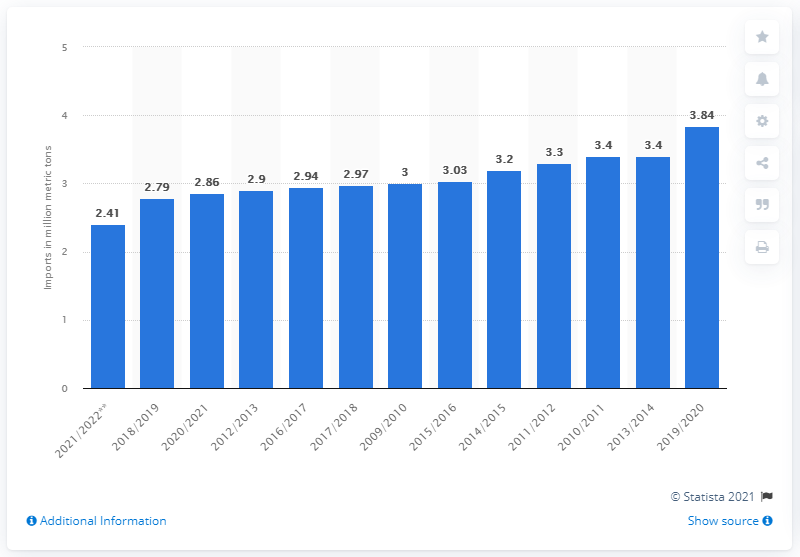List a handful of essential elements in this visual. In 2016/2017, the United States imported 2.94 million metric tons of sugar. 